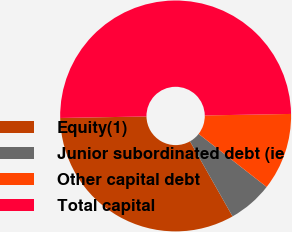Convert chart. <chart><loc_0><loc_0><loc_500><loc_500><pie_chart><fcel>Equity(1)<fcel>Junior subordinated debt (ie<fcel>Other capital debt<fcel>Total capital<nl><fcel>32.93%<fcel>6.25%<fcel>10.82%<fcel>50.0%<nl></chart> 